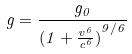Convert formula to latex. <formula><loc_0><loc_0><loc_500><loc_500>g = \frac { g _ { 0 } } { ( { 1 + \frac { v ^ { 6 } } { c ^ { 6 } } ) } ^ { 9 / 6 } }</formula> 